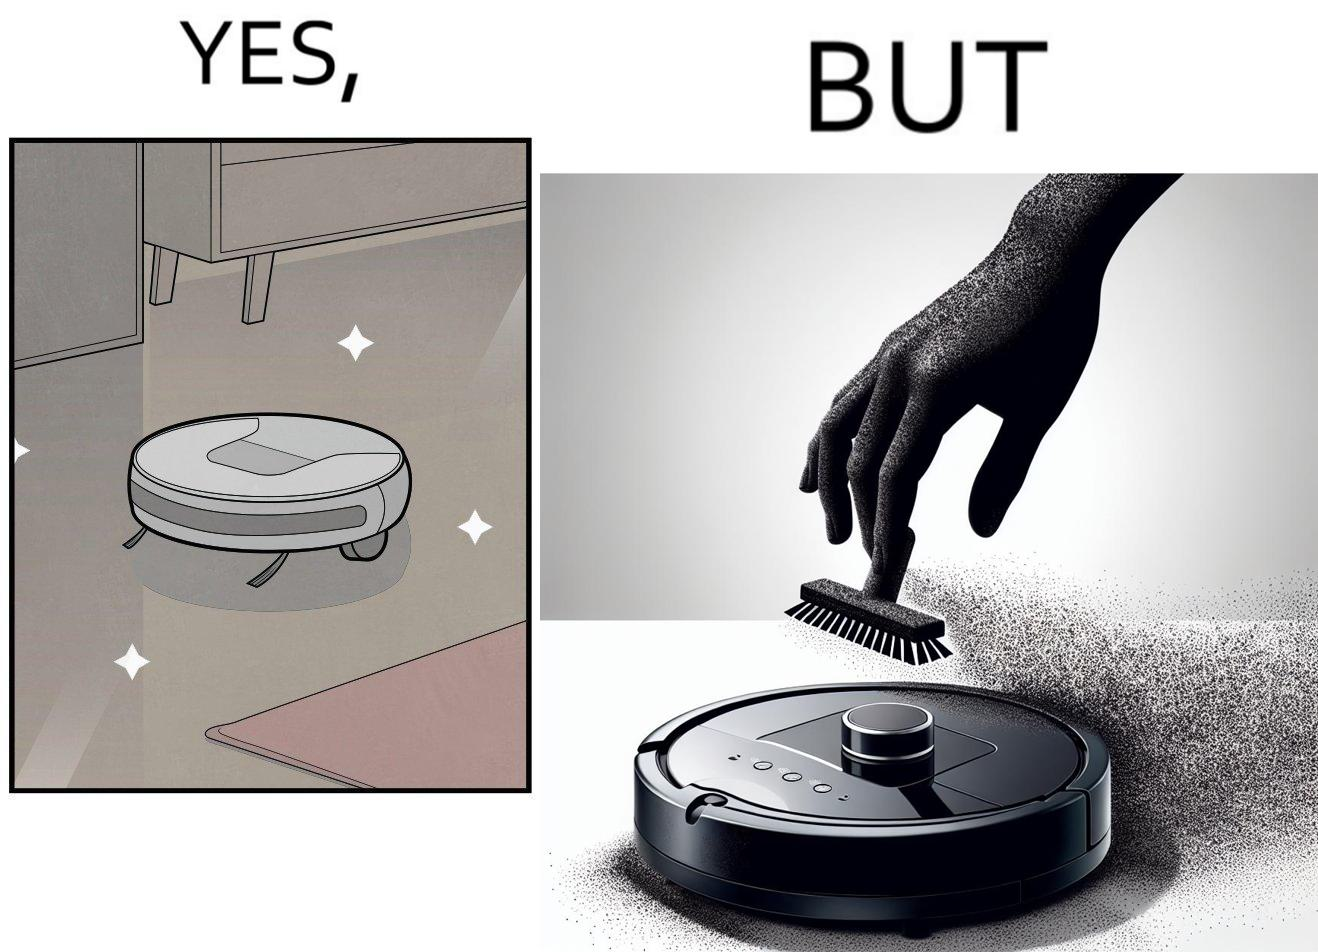What is the satirical meaning behind this image? This is funny, because the machine while doing its job cleans everything but ends up being dirty itself. 